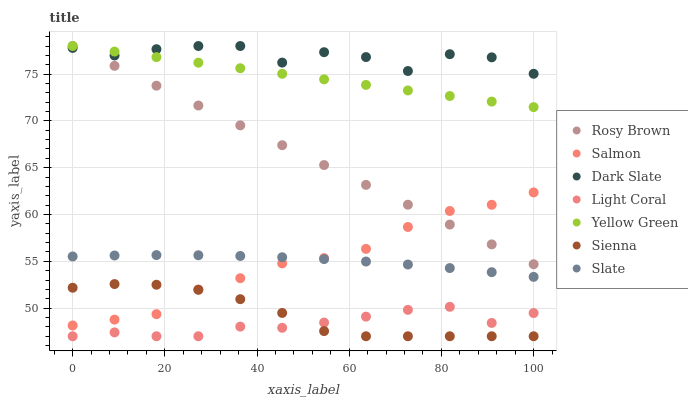Does Light Coral have the minimum area under the curve?
Answer yes or no. Yes. Does Dark Slate have the maximum area under the curve?
Answer yes or no. Yes. Does Yellow Green have the minimum area under the curve?
Answer yes or no. No. Does Yellow Green have the maximum area under the curve?
Answer yes or no. No. Is Yellow Green the smoothest?
Answer yes or no. Yes. Is Dark Slate the roughest?
Answer yes or no. Yes. Is Slate the smoothest?
Answer yes or no. No. Is Slate the roughest?
Answer yes or no. No. Does Sienna have the lowest value?
Answer yes or no. Yes. Does Yellow Green have the lowest value?
Answer yes or no. No. Does Dark Slate have the highest value?
Answer yes or no. Yes. Does Slate have the highest value?
Answer yes or no. No. Is Slate less than Dark Slate?
Answer yes or no. Yes. Is Slate greater than Light Coral?
Answer yes or no. Yes. Does Salmon intersect Sienna?
Answer yes or no. Yes. Is Salmon less than Sienna?
Answer yes or no. No. Is Salmon greater than Sienna?
Answer yes or no. No. Does Slate intersect Dark Slate?
Answer yes or no. No. 